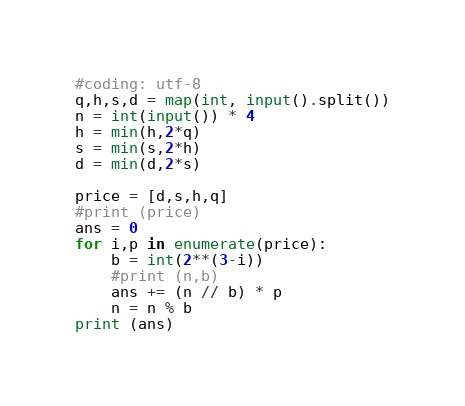<code> <loc_0><loc_0><loc_500><loc_500><_Python_>#coding: utf-8
q,h,s,d = map(int, input().split())
n = int(input()) * 4
h = min(h,2*q)
s = min(s,2*h)
d = min(d,2*s)

price = [d,s,h,q]
#print (price)
ans = 0
for i,p in enumerate(price):
    b = int(2**(3-i))
    #print (n,b)
    ans += (n // b) * p
    n = n % b
print (ans)
</code> 